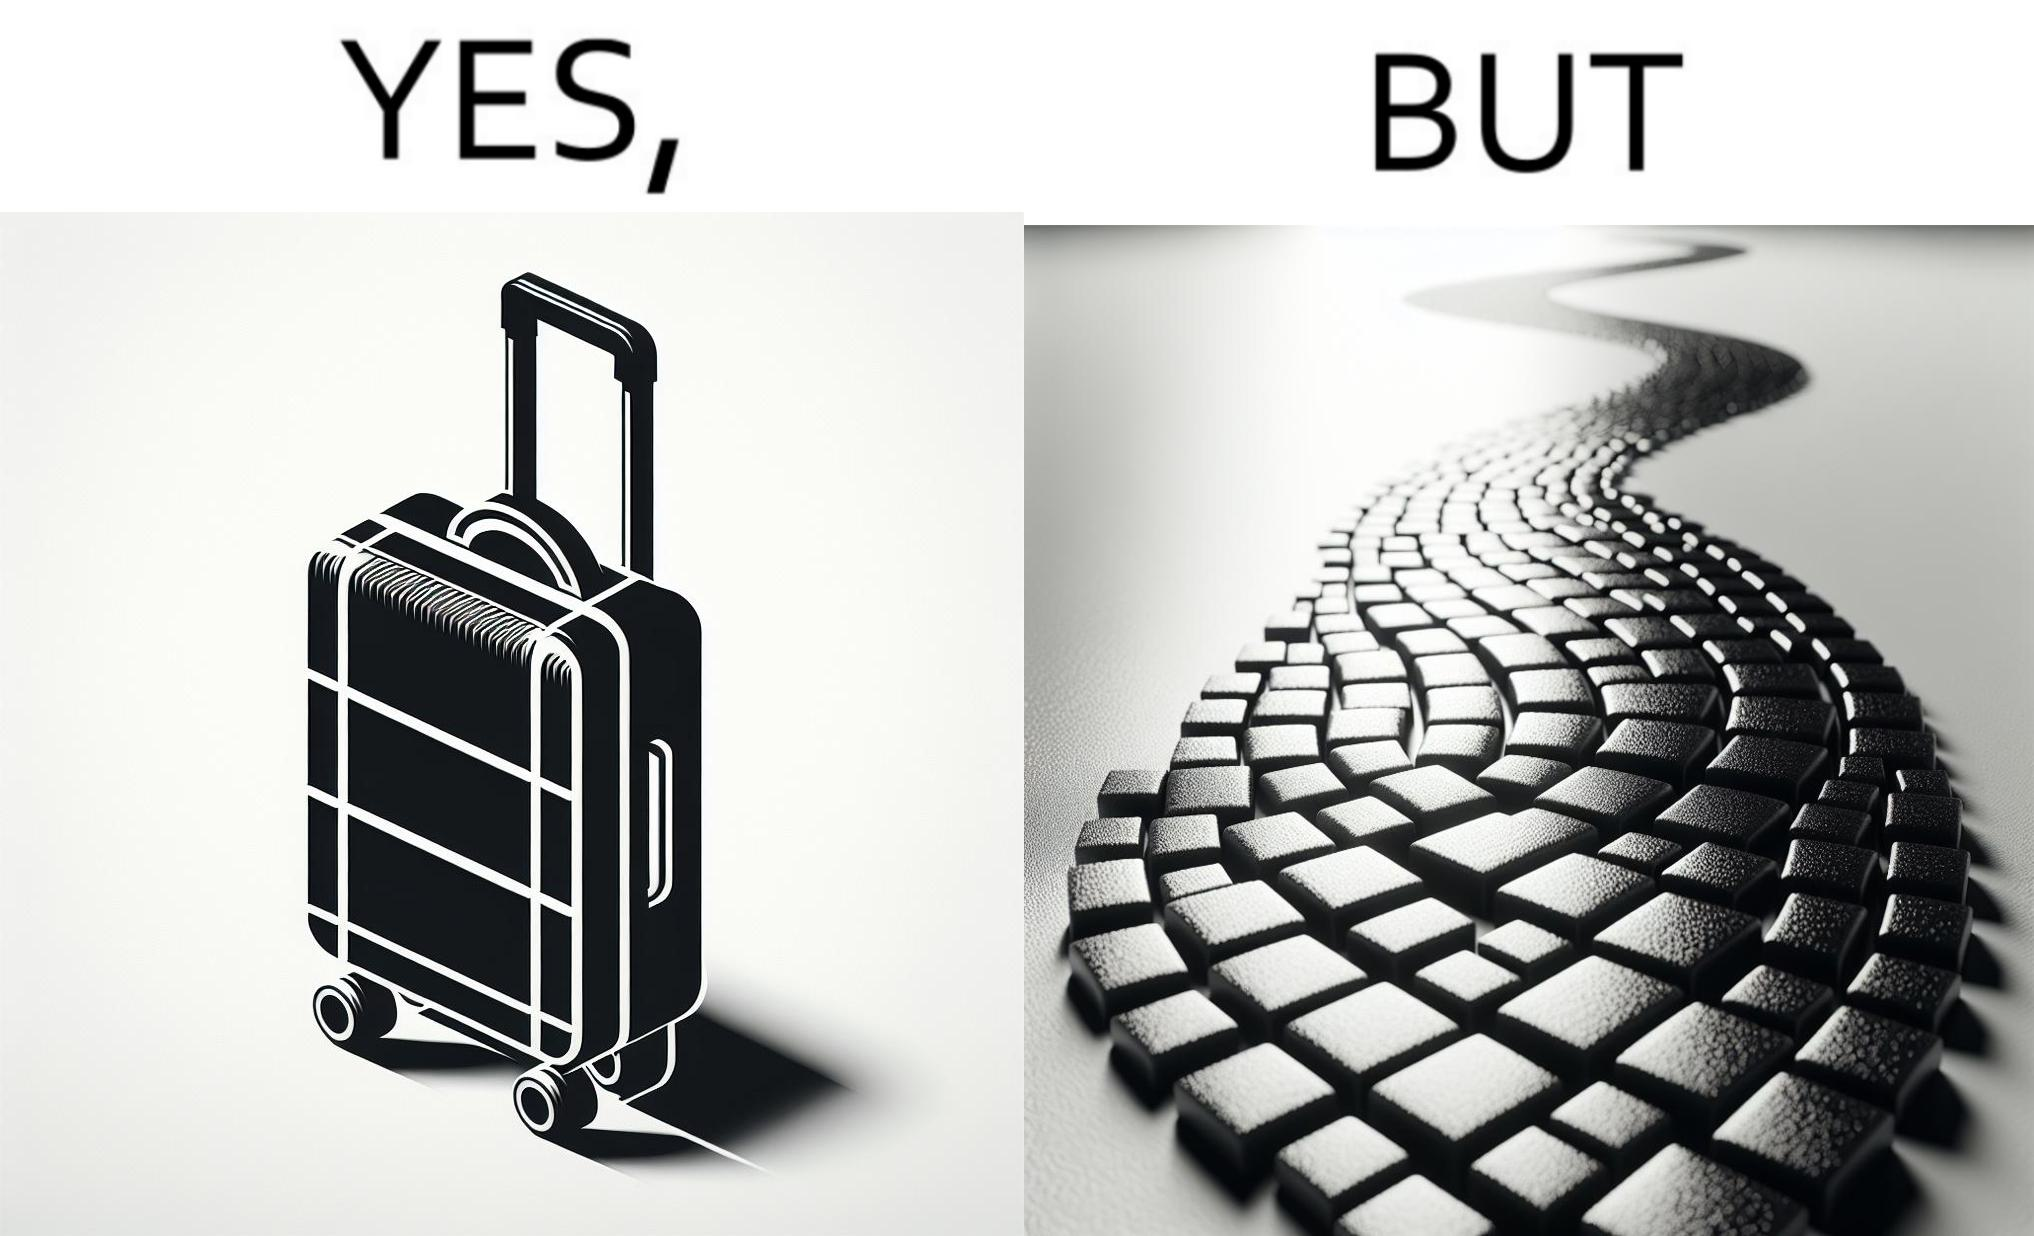Describe the content of this image. The image is funny because even though the trolley bag is made to make carrying luggage easy, as soon as it encounters a rough surface like cobblestone road, it makes carrying luggage more difficult. 